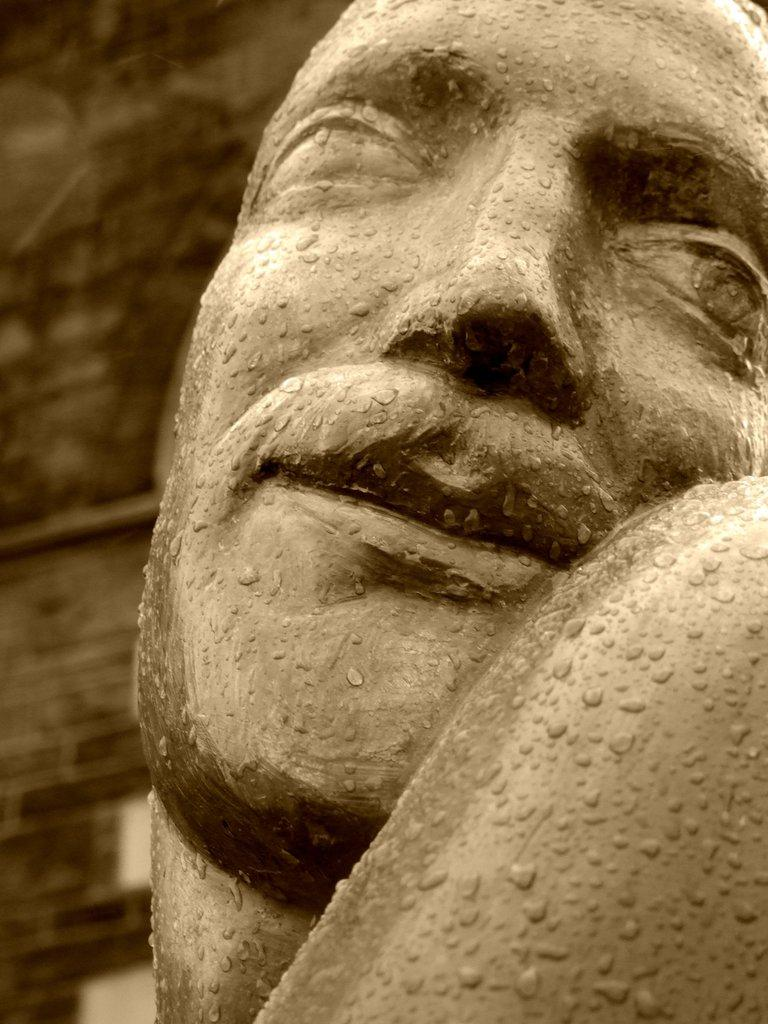What is the color scheme of the image? The image is black and white. What is the main subject in the image? There is a statue in the image. Can you describe the statue's condition? The statue has tiny droplets of water on it. What else can be seen in the image besides the statue? There is a wall visible in the image. What type of copper fowl can be seen on the statue in the image? There is no copper fowl present on the statue in the image. What punishment is being depicted in the image? There is no punishment being depicted in the image; it features a statue with droplets of water on it and a wall in the background. 